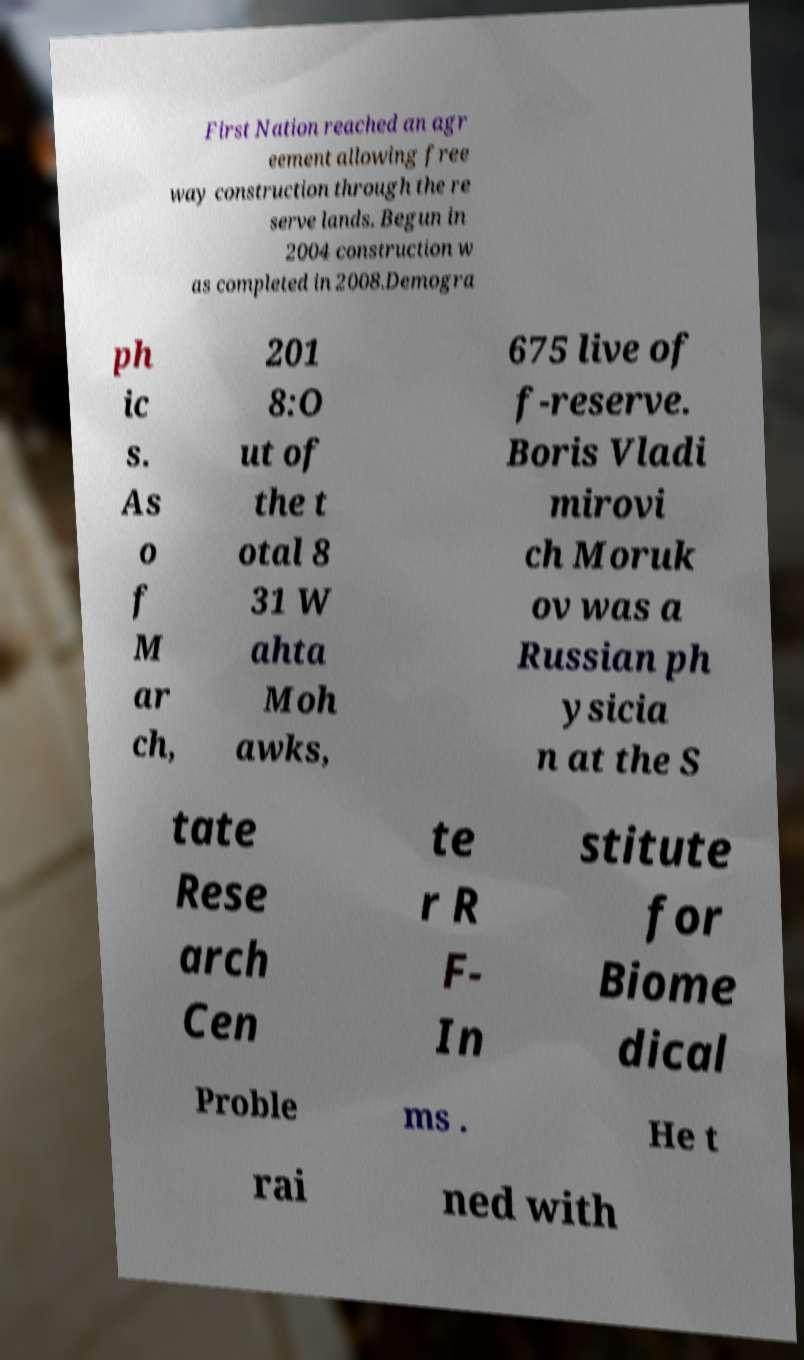What messages or text are displayed in this image? I need them in a readable, typed format. First Nation reached an agr eement allowing free way construction through the re serve lands. Begun in 2004 construction w as completed in 2008.Demogra ph ic s. As o f M ar ch, 201 8:O ut of the t otal 8 31 W ahta Moh awks, 675 live of f-reserve. Boris Vladi mirovi ch Moruk ov was a Russian ph ysicia n at the S tate Rese arch Cen te r R F- In stitute for Biome dical Proble ms . He t rai ned with 